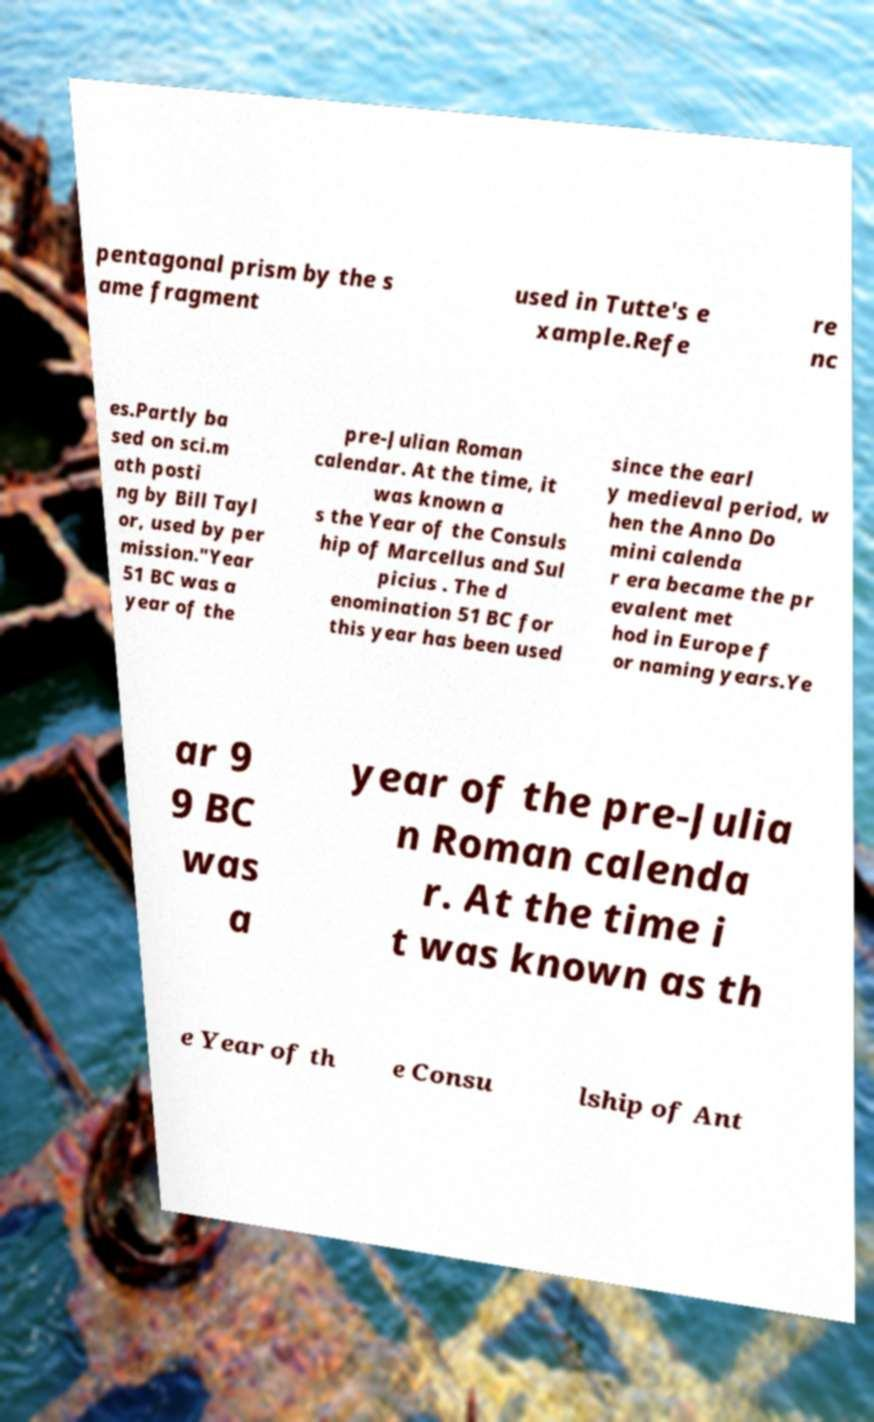Can you read and provide the text displayed in the image?This photo seems to have some interesting text. Can you extract and type it out for me? pentagonal prism by the s ame fragment used in Tutte's e xample.Refe re nc es.Partly ba sed on sci.m ath posti ng by Bill Tayl or, used by per mission."Year 51 BC was a year of the pre-Julian Roman calendar. At the time, it was known a s the Year of the Consuls hip of Marcellus and Sul picius . The d enomination 51 BC for this year has been used since the earl y medieval period, w hen the Anno Do mini calenda r era became the pr evalent met hod in Europe f or naming years.Ye ar 9 9 BC was a year of the pre-Julia n Roman calenda r. At the time i t was known as th e Year of th e Consu lship of Ant 